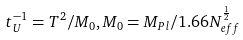Convert formula to latex. <formula><loc_0><loc_0><loc_500><loc_500>t _ { U } ^ { - 1 } = T ^ { 2 } / M _ { 0 } , M _ { 0 } = M _ { P l } / 1 . 6 6 N _ { e f f } ^ { \frac { 1 } { 2 } }</formula> 